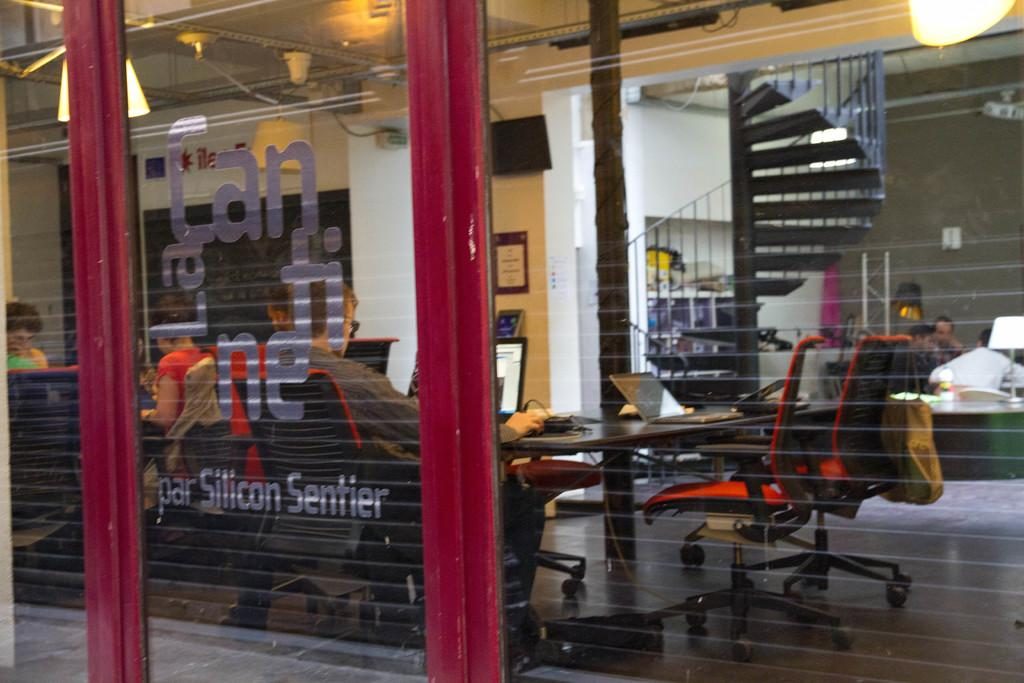<image>
Offer a succinct explanation of the picture presented. an office building with par Silicon Sentier on it 